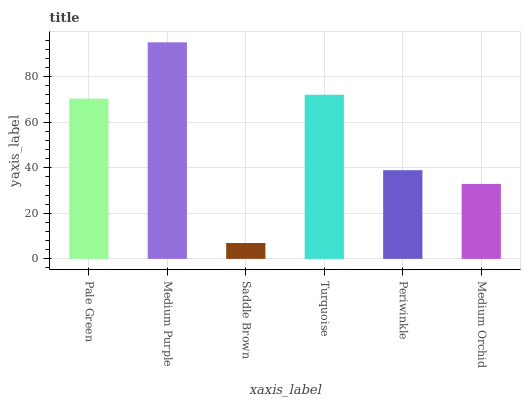Is Saddle Brown the minimum?
Answer yes or no. Yes. Is Medium Purple the maximum?
Answer yes or no. Yes. Is Medium Purple the minimum?
Answer yes or no. No. Is Saddle Brown the maximum?
Answer yes or no. No. Is Medium Purple greater than Saddle Brown?
Answer yes or no. Yes. Is Saddle Brown less than Medium Purple?
Answer yes or no. Yes. Is Saddle Brown greater than Medium Purple?
Answer yes or no. No. Is Medium Purple less than Saddle Brown?
Answer yes or no. No. Is Pale Green the high median?
Answer yes or no. Yes. Is Periwinkle the low median?
Answer yes or no. Yes. Is Turquoise the high median?
Answer yes or no. No. Is Medium Purple the low median?
Answer yes or no. No. 